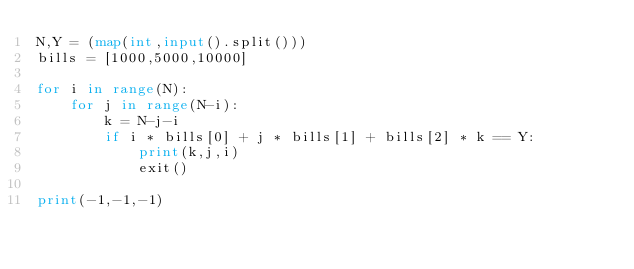<code> <loc_0><loc_0><loc_500><loc_500><_Python_>N,Y = (map(int,input().split()))
bills = [1000,5000,10000]

for i in range(N):
    for j in range(N-i):
        k = N-j-i
        if i * bills[0] + j * bills[1] + bills[2] * k == Y:
            print(k,j,i)
            exit()

print(-1,-1,-1)</code> 